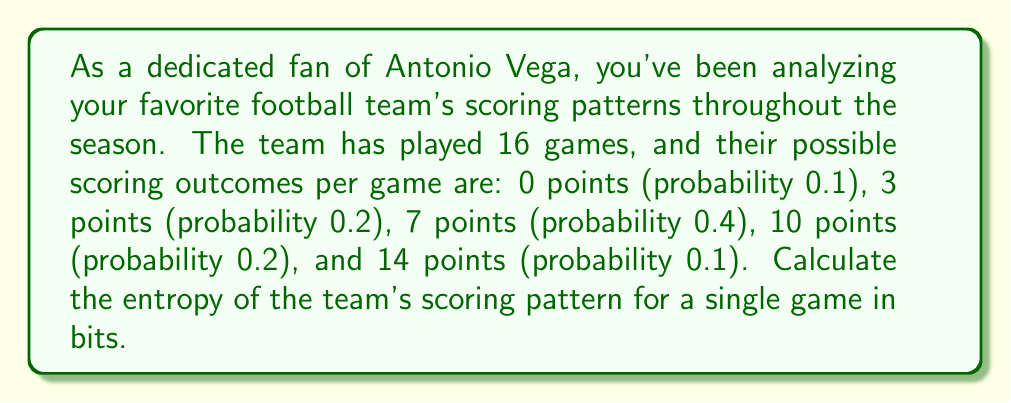Provide a solution to this math problem. To solve this problem, we'll use the entropy formula from information theory. The entropy $H$ of a discrete random variable $X$ with possible values $\{x_1, ..., x_n\}$ and probability mass function $P(X)$ is given by:

$$H(X) = -\sum_{i=1}^n P(x_i) \log_2 P(x_i)$$

Let's break down the calculation step by step:

1) First, we'll list out our probabilities:
   $P(0) = 0.1$
   $P(3) = 0.2$
   $P(7) = 0.4$
   $P(10) = 0.2$
   $P(14) = 0.1$

2) Now, we'll calculate each term in the sum:

   For 0 points: $-0.1 \log_2(0.1) \approx 0.3322$
   For 3 points: $-0.2 \log_2(0.2) \approx 0.4644$
   For 7 points: $-0.4 \log_2(0.4) \approx 0.5288$
   For 10 points: $-0.2 \log_2(0.2) \approx 0.4644$
   For 14 points: $-0.1 \log_2(0.1) \approx 0.3322$

3) Sum up all these terms:

   $H(X) = 0.3322 + 0.4644 + 0.5288 + 0.4644 + 0.3322 = 2.1220$

Therefore, the entropy of the team's scoring pattern for a single game is approximately 2.1220 bits.
Answer: $2.1220$ bits 